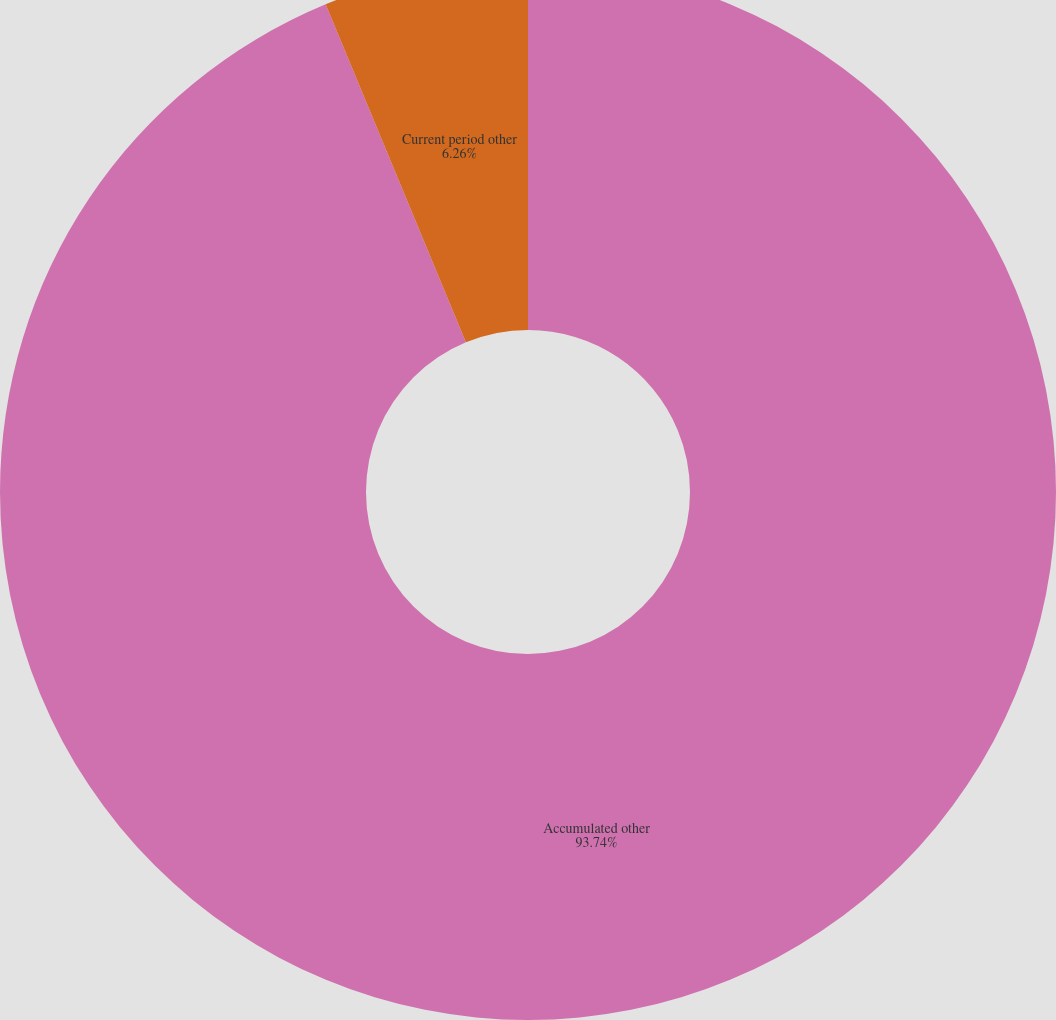Convert chart to OTSL. <chart><loc_0><loc_0><loc_500><loc_500><pie_chart><fcel>Accumulated other<fcel>Current period other<nl><fcel>93.74%<fcel>6.26%<nl></chart> 